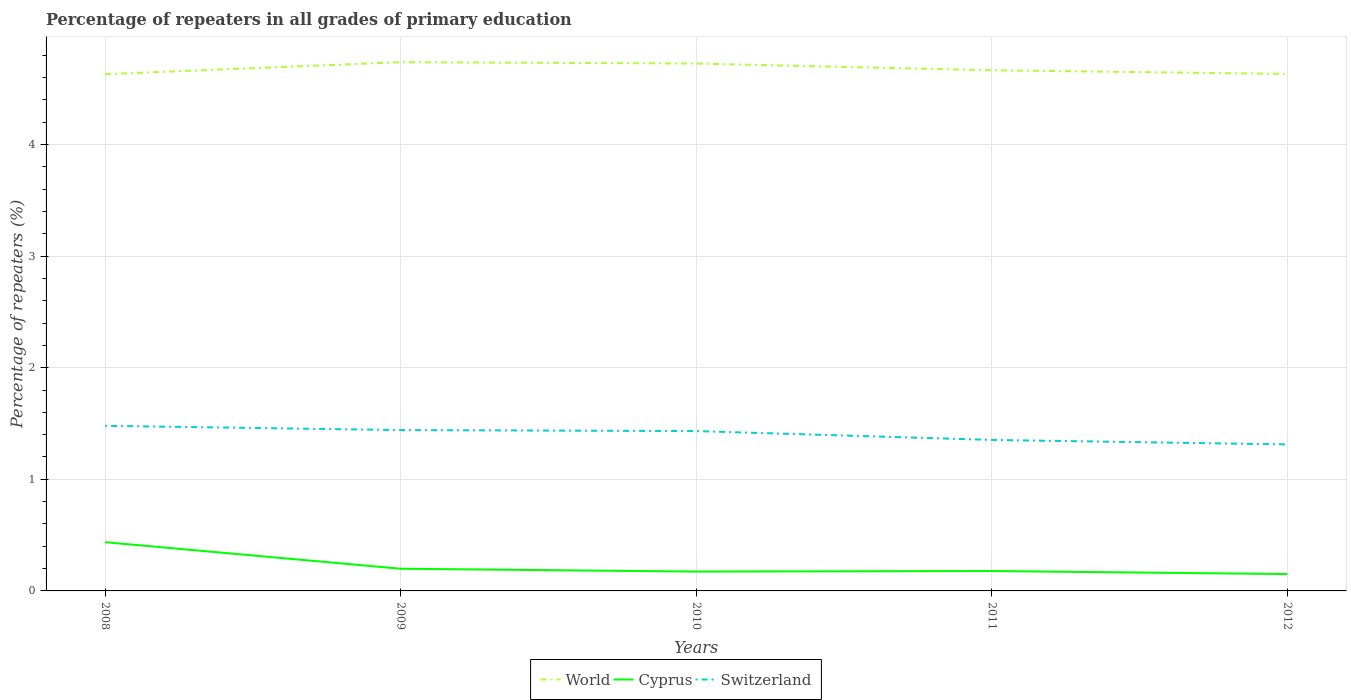How many different coloured lines are there?
Ensure brevity in your answer.  3. Across all years, what is the maximum percentage of repeaters in Cyprus?
Offer a terse response. 0.15. What is the total percentage of repeaters in World in the graph?
Offer a terse response. -0. What is the difference between the highest and the second highest percentage of repeaters in World?
Provide a short and direct response. 0.11. How many years are there in the graph?
Provide a short and direct response. 5. What is the difference between two consecutive major ticks on the Y-axis?
Offer a very short reply. 1. Does the graph contain grids?
Your answer should be compact. Yes. What is the title of the graph?
Give a very brief answer. Percentage of repeaters in all grades of primary education. What is the label or title of the X-axis?
Keep it short and to the point. Years. What is the label or title of the Y-axis?
Offer a terse response. Percentage of repeaters (%). What is the Percentage of repeaters (%) of World in 2008?
Provide a short and direct response. 4.63. What is the Percentage of repeaters (%) of Cyprus in 2008?
Offer a terse response. 0.44. What is the Percentage of repeaters (%) in Switzerland in 2008?
Your answer should be very brief. 1.48. What is the Percentage of repeaters (%) of World in 2009?
Keep it short and to the point. 4.74. What is the Percentage of repeaters (%) in Cyprus in 2009?
Provide a succinct answer. 0.2. What is the Percentage of repeaters (%) of Switzerland in 2009?
Your response must be concise. 1.44. What is the Percentage of repeaters (%) of World in 2010?
Keep it short and to the point. 4.73. What is the Percentage of repeaters (%) in Cyprus in 2010?
Ensure brevity in your answer.  0.17. What is the Percentage of repeaters (%) in Switzerland in 2010?
Your answer should be very brief. 1.43. What is the Percentage of repeaters (%) of World in 2011?
Ensure brevity in your answer.  4.67. What is the Percentage of repeaters (%) in Cyprus in 2011?
Provide a succinct answer. 0.18. What is the Percentage of repeaters (%) in Switzerland in 2011?
Offer a very short reply. 1.35. What is the Percentage of repeaters (%) in World in 2012?
Offer a terse response. 4.63. What is the Percentage of repeaters (%) in Cyprus in 2012?
Offer a terse response. 0.15. What is the Percentage of repeaters (%) in Switzerland in 2012?
Keep it short and to the point. 1.31. Across all years, what is the maximum Percentage of repeaters (%) of World?
Keep it short and to the point. 4.74. Across all years, what is the maximum Percentage of repeaters (%) of Cyprus?
Offer a very short reply. 0.44. Across all years, what is the maximum Percentage of repeaters (%) in Switzerland?
Give a very brief answer. 1.48. Across all years, what is the minimum Percentage of repeaters (%) in World?
Your answer should be very brief. 4.63. Across all years, what is the minimum Percentage of repeaters (%) of Cyprus?
Provide a succinct answer. 0.15. Across all years, what is the minimum Percentage of repeaters (%) in Switzerland?
Offer a terse response. 1.31. What is the total Percentage of repeaters (%) of World in the graph?
Your answer should be compact. 23.39. What is the total Percentage of repeaters (%) in Cyprus in the graph?
Your answer should be very brief. 1.14. What is the total Percentage of repeaters (%) in Switzerland in the graph?
Ensure brevity in your answer.  7.02. What is the difference between the Percentage of repeaters (%) in World in 2008 and that in 2009?
Offer a very short reply. -0.11. What is the difference between the Percentage of repeaters (%) of Cyprus in 2008 and that in 2009?
Offer a terse response. 0.24. What is the difference between the Percentage of repeaters (%) in Switzerland in 2008 and that in 2009?
Provide a short and direct response. 0.04. What is the difference between the Percentage of repeaters (%) in World in 2008 and that in 2010?
Offer a very short reply. -0.1. What is the difference between the Percentage of repeaters (%) of Cyprus in 2008 and that in 2010?
Offer a very short reply. 0.26. What is the difference between the Percentage of repeaters (%) in Switzerland in 2008 and that in 2010?
Keep it short and to the point. 0.05. What is the difference between the Percentage of repeaters (%) of World in 2008 and that in 2011?
Your answer should be very brief. -0.03. What is the difference between the Percentage of repeaters (%) of Cyprus in 2008 and that in 2011?
Keep it short and to the point. 0.26. What is the difference between the Percentage of repeaters (%) in Switzerland in 2008 and that in 2011?
Your answer should be compact. 0.13. What is the difference between the Percentage of repeaters (%) of World in 2008 and that in 2012?
Offer a very short reply. -0. What is the difference between the Percentage of repeaters (%) in Cyprus in 2008 and that in 2012?
Your answer should be compact. 0.29. What is the difference between the Percentage of repeaters (%) of Switzerland in 2008 and that in 2012?
Keep it short and to the point. 0.17. What is the difference between the Percentage of repeaters (%) of World in 2009 and that in 2010?
Make the answer very short. 0.01. What is the difference between the Percentage of repeaters (%) of Cyprus in 2009 and that in 2010?
Ensure brevity in your answer.  0.03. What is the difference between the Percentage of repeaters (%) of Switzerland in 2009 and that in 2010?
Make the answer very short. 0.01. What is the difference between the Percentage of repeaters (%) in World in 2009 and that in 2011?
Make the answer very short. 0.07. What is the difference between the Percentage of repeaters (%) in Cyprus in 2009 and that in 2011?
Offer a very short reply. 0.02. What is the difference between the Percentage of repeaters (%) in Switzerland in 2009 and that in 2011?
Your answer should be very brief. 0.09. What is the difference between the Percentage of repeaters (%) of World in 2009 and that in 2012?
Offer a terse response. 0.11. What is the difference between the Percentage of repeaters (%) in Cyprus in 2009 and that in 2012?
Your answer should be compact. 0.05. What is the difference between the Percentage of repeaters (%) in Switzerland in 2009 and that in 2012?
Provide a short and direct response. 0.13. What is the difference between the Percentage of repeaters (%) of World in 2010 and that in 2011?
Your answer should be compact. 0.06. What is the difference between the Percentage of repeaters (%) in Cyprus in 2010 and that in 2011?
Offer a terse response. -0.01. What is the difference between the Percentage of repeaters (%) in Switzerland in 2010 and that in 2011?
Your response must be concise. 0.08. What is the difference between the Percentage of repeaters (%) of World in 2010 and that in 2012?
Provide a succinct answer. 0.09. What is the difference between the Percentage of repeaters (%) in Cyprus in 2010 and that in 2012?
Your response must be concise. 0.02. What is the difference between the Percentage of repeaters (%) of Switzerland in 2010 and that in 2012?
Your response must be concise. 0.12. What is the difference between the Percentage of repeaters (%) in World in 2011 and that in 2012?
Provide a short and direct response. 0.03. What is the difference between the Percentage of repeaters (%) of Cyprus in 2011 and that in 2012?
Ensure brevity in your answer.  0.03. What is the difference between the Percentage of repeaters (%) in Switzerland in 2011 and that in 2012?
Ensure brevity in your answer.  0.04. What is the difference between the Percentage of repeaters (%) of World in 2008 and the Percentage of repeaters (%) of Cyprus in 2009?
Offer a terse response. 4.43. What is the difference between the Percentage of repeaters (%) of World in 2008 and the Percentage of repeaters (%) of Switzerland in 2009?
Provide a short and direct response. 3.19. What is the difference between the Percentage of repeaters (%) in Cyprus in 2008 and the Percentage of repeaters (%) in Switzerland in 2009?
Your response must be concise. -1. What is the difference between the Percentage of repeaters (%) in World in 2008 and the Percentage of repeaters (%) in Cyprus in 2010?
Your response must be concise. 4.46. What is the difference between the Percentage of repeaters (%) of World in 2008 and the Percentage of repeaters (%) of Switzerland in 2010?
Keep it short and to the point. 3.2. What is the difference between the Percentage of repeaters (%) of Cyprus in 2008 and the Percentage of repeaters (%) of Switzerland in 2010?
Offer a very short reply. -1. What is the difference between the Percentage of repeaters (%) of World in 2008 and the Percentage of repeaters (%) of Cyprus in 2011?
Make the answer very short. 4.45. What is the difference between the Percentage of repeaters (%) in World in 2008 and the Percentage of repeaters (%) in Switzerland in 2011?
Ensure brevity in your answer.  3.28. What is the difference between the Percentage of repeaters (%) of Cyprus in 2008 and the Percentage of repeaters (%) of Switzerland in 2011?
Offer a very short reply. -0.92. What is the difference between the Percentage of repeaters (%) in World in 2008 and the Percentage of repeaters (%) in Cyprus in 2012?
Keep it short and to the point. 4.48. What is the difference between the Percentage of repeaters (%) of World in 2008 and the Percentage of repeaters (%) of Switzerland in 2012?
Your answer should be very brief. 3.32. What is the difference between the Percentage of repeaters (%) in Cyprus in 2008 and the Percentage of repeaters (%) in Switzerland in 2012?
Your answer should be compact. -0.88. What is the difference between the Percentage of repeaters (%) in World in 2009 and the Percentage of repeaters (%) in Cyprus in 2010?
Your response must be concise. 4.56. What is the difference between the Percentage of repeaters (%) in World in 2009 and the Percentage of repeaters (%) in Switzerland in 2010?
Your answer should be compact. 3.31. What is the difference between the Percentage of repeaters (%) of Cyprus in 2009 and the Percentage of repeaters (%) of Switzerland in 2010?
Ensure brevity in your answer.  -1.23. What is the difference between the Percentage of repeaters (%) of World in 2009 and the Percentage of repeaters (%) of Cyprus in 2011?
Provide a short and direct response. 4.56. What is the difference between the Percentage of repeaters (%) of World in 2009 and the Percentage of repeaters (%) of Switzerland in 2011?
Give a very brief answer. 3.38. What is the difference between the Percentage of repeaters (%) in Cyprus in 2009 and the Percentage of repeaters (%) in Switzerland in 2011?
Offer a very short reply. -1.15. What is the difference between the Percentage of repeaters (%) of World in 2009 and the Percentage of repeaters (%) of Cyprus in 2012?
Your response must be concise. 4.59. What is the difference between the Percentage of repeaters (%) of World in 2009 and the Percentage of repeaters (%) of Switzerland in 2012?
Offer a very short reply. 3.43. What is the difference between the Percentage of repeaters (%) in Cyprus in 2009 and the Percentage of repeaters (%) in Switzerland in 2012?
Provide a short and direct response. -1.11. What is the difference between the Percentage of repeaters (%) of World in 2010 and the Percentage of repeaters (%) of Cyprus in 2011?
Offer a terse response. 4.55. What is the difference between the Percentage of repeaters (%) in World in 2010 and the Percentage of repeaters (%) in Switzerland in 2011?
Your response must be concise. 3.37. What is the difference between the Percentage of repeaters (%) in Cyprus in 2010 and the Percentage of repeaters (%) in Switzerland in 2011?
Offer a terse response. -1.18. What is the difference between the Percentage of repeaters (%) of World in 2010 and the Percentage of repeaters (%) of Cyprus in 2012?
Offer a terse response. 4.57. What is the difference between the Percentage of repeaters (%) of World in 2010 and the Percentage of repeaters (%) of Switzerland in 2012?
Your answer should be compact. 3.41. What is the difference between the Percentage of repeaters (%) of Cyprus in 2010 and the Percentage of repeaters (%) of Switzerland in 2012?
Offer a terse response. -1.14. What is the difference between the Percentage of repeaters (%) in World in 2011 and the Percentage of repeaters (%) in Cyprus in 2012?
Your answer should be compact. 4.51. What is the difference between the Percentage of repeaters (%) of World in 2011 and the Percentage of repeaters (%) of Switzerland in 2012?
Provide a succinct answer. 3.35. What is the difference between the Percentage of repeaters (%) of Cyprus in 2011 and the Percentage of repeaters (%) of Switzerland in 2012?
Keep it short and to the point. -1.13. What is the average Percentage of repeaters (%) in World per year?
Give a very brief answer. 4.68. What is the average Percentage of repeaters (%) in Cyprus per year?
Give a very brief answer. 0.23. What is the average Percentage of repeaters (%) of Switzerland per year?
Provide a short and direct response. 1.4. In the year 2008, what is the difference between the Percentage of repeaters (%) of World and Percentage of repeaters (%) of Cyprus?
Offer a terse response. 4.19. In the year 2008, what is the difference between the Percentage of repeaters (%) in World and Percentage of repeaters (%) in Switzerland?
Give a very brief answer. 3.15. In the year 2008, what is the difference between the Percentage of repeaters (%) in Cyprus and Percentage of repeaters (%) in Switzerland?
Make the answer very short. -1.04. In the year 2009, what is the difference between the Percentage of repeaters (%) in World and Percentage of repeaters (%) in Cyprus?
Offer a terse response. 4.54. In the year 2009, what is the difference between the Percentage of repeaters (%) in World and Percentage of repeaters (%) in Switzerland?
Offer a terse response. 3.3. In the year 2009, what is the difference between the Percentage of repeaters (%) of Cyprus and Percentage of repeaters (%) of Switzerland?
Offer a terse response. -1.24. In the year 2010, what is the difference between the Percentage of repeaters (%) of World and Percentage of repeaters (%) of Cyprus?
Offer a terse response. 4.55. In the year 2010, what is the difference between the Percentage of repeaters (%) in World and Percentage of repeaters (%) in Switzerland?
Offer a terse response. 3.29. In the year 2010, what is the difference between the Percentage of repeaters (%) of Cyprus and Percentage of repeaters (%) of Switzerland?
Make the answer very short. -1.26. In the year 2011, what is the difference between the Percentage of repeaters (%) of World and Percentage of repeaters (%) of Cyprus?
Give a very brief answer. 4.49. In the year 2011, what is the difference between the Percentage of repeaters (%) in World and Percentage of repeaters (%) in Switzerland?
Provide a succinct answer. 3.31. In the year 2011, what is the difference between the Percentage of repeaters (%) in Cyprus and Percentage of repeaters (%) in Switzerland?
Offer a terse response. -1.17. In the year 2012, what is the difference between the Percentage of repeaters (%) of World and Percentage of repeaters (%) of Cyprus?
Make the answer very short. 4.48. In the year 2012, what is the difference between the Percentage of repeaters (%) of World and Percentage of repeaters (%) of Switzerland?
Your response must be concise. 3.32. In the year 2012, what is the difference between the Percentage of repeaters (%) in Cyprus and Percentage of repeaters (%) in Switzerland?
Give a very brief answer. -1.16. What is the ratio of the Percentage of repeaters (%) in World in 2008 to that in 2009?
Offer a very short reply. 0.98. What is the ratio of the Percentage of repeaters (%) in Cyprus in 2008 to that in 2009?
Give a very brief answer. 2.2. What is the ratio of the Percentage of repeaters (%) in Switzerland in 2008 to that in 2009?
Your answer should be very brief. 1.03. What is the ratio of the Percentage of repeaters (%) in World in 2008 to that in 2010?
Provide a succinct answer. 0.98. What is the ratio of the Percentage of repeaters (%) of Cyprus in 2008 to that in 2010?
Provide a short and direct response. 2.52. What is the ratio of the Percentage of repeaters (%) in Switzerland in 2008 to that in 2010?
Keep it short and to the point. 1.03. What is the ratio of the Percentage of repeaters (%) of World in 2008 to that in 2011?
Ensure brevity in your answer.  0.99. What is the ratio of the Percentage of repeaters (%) of Cyprus in 2008 to that in 2011?
Keep it short and to the point. 2.45. What is the ratio of the Percentage of repeaters (%) of Switzerland in 2008 to that in 2011?
Provide a succinct answer. 1.09. What is the ratio of the Percentage of repeaters (%) of Cyprus in 2008 to that in 2012?
Offer a terse response. 2.89. What is the ratio of the Percentage of repeaters (%) in Switzerland in 2008 to that in 2012?
Provide a succinct answer. 1.13. What is the ratio of the Percentage of repeaters (%) of Cyprus in 2009 to that in 2010?
Offer a terse response. 1.15. What is the ratio of the Percentage of repeaters (%) in Switzerland in 2009 to that in 2010?
Your response must be concise. 1.01. What is the ratio of the Percentage of repeaters (%) in World in 2009 to that in 2011?
Your response must be concise. 1.02. What is the ratio of the Percentage of repeaters (%) of Cyprus in 2009 to that in 2011?
Ensure brevity in your answer.  1.11. What is the ratio of the Percentage of repeaters (%) of Switzerland in 2009 to that in 2011?
Provide a succinct answer. 1.07. What is the ratio of the Percentage of repeaters (%) of World in 2009 to that in 2012?
Offer a terse response. 1.02. What is the ratio of the Percentage of repeaters (%) of Cyprus in 2009 to that in 2012?
Provide a succinct answer. 1.32. What is the ratio of the Percentage of repeaters (%) of Switzerland in 2009 to that in 2012?
Give a very brief answer. 1.1. What is the ratio of the Percentage of repeaters (%) of World in 2010 to that in 2011?
Your answer should be very brief. 1.01. What is the ratio of the Percentage of repeaters (%) in Cyprus in 2010 to that in 2011?
Your answer should be compact. 0.97. What is the ratio of the Percentage of repeaters (%) of Switzerland in 2010 to that in 2011?
Your answer should be compact. 1.06. What is the ratio of the Percentage of repeaters (%) in World in 2010 to that in 2012?
Your answer should be very brief. 1.02. What is the ratio of the Percentage of repeaters (%) of Cyprus in 2010 to that in 2012?
Your answer should be compact. 1.15. What is the ratio of the Percentage of repeaters (%) in Switzerland in 2010 to that in 2012?
Your answer should be compact. 1.09. What is the ratio of the Percentage of repeaters (%) in World in 2011 to that in 2012?
Provide a short and direct response. 1.01. What is the ratio of the Percentage of repeaters (%) in Cyprus in 2011 to that in 2012?
Keep it short and to the point. 1.18. What is the ratio of the Percentage of repeaters (%) in Switzerland in 2011 to that in 2012?
Your response must be concise. 1.03. What is the difference between the highest and the second highest Percentage of repeaters (%) of World?
Provide a short and direct response. 0.01. What is the difference between the highest and the second highest Percentage of repeaters (%) of Cyprus?
Offer a terse response. 0.24. What is the difference between the highest and the second highest Percentage of repeaters (%) in Switzerland?
Your answer should be compact. 0.04. What is the difference between the highest and the lowest Percentage of repeaters (%) of World?
Your answer should be very brief. 0.11. What is the difference between the highest and the lowest Percentage of repeaters (%) in Cyprus?
Make the answer very short. 0.29. What is the difference between the highest and the lowest Percentage of repeaters (%) of Switzerland?
Make the answer very short. 0.17. 